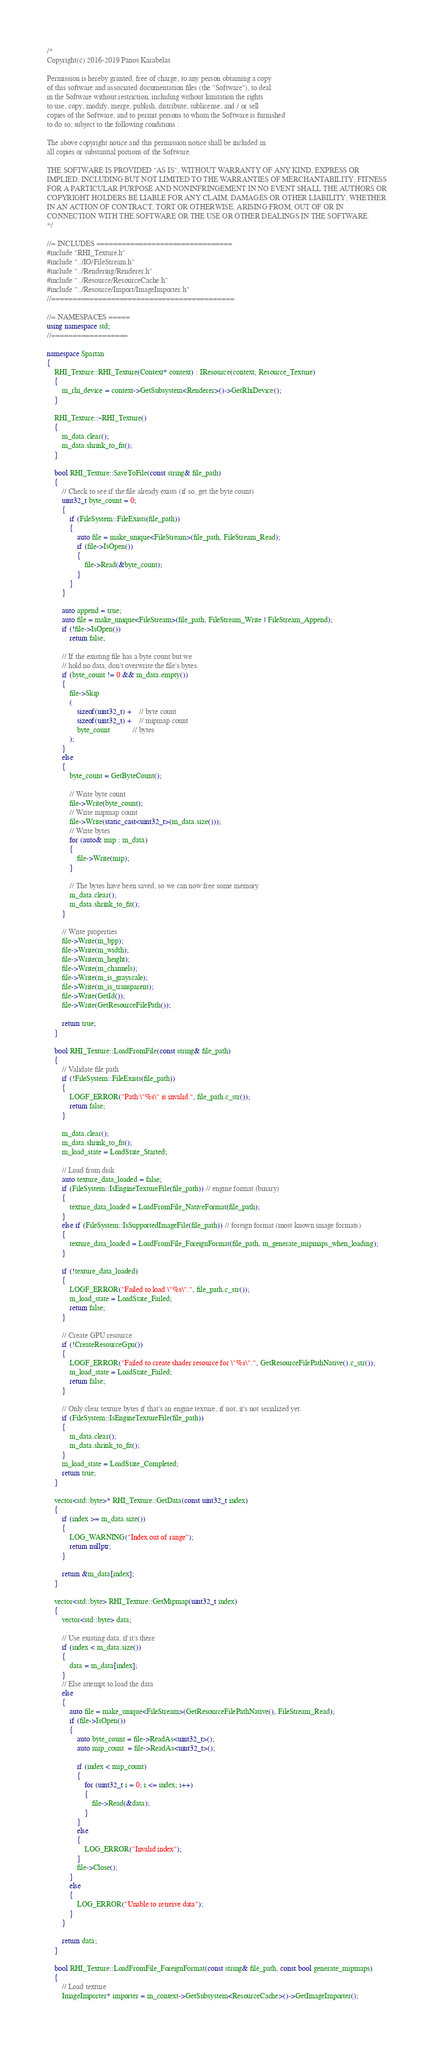Convert code to text. <code><loc_0><loc_0><loc_500><loc_500><_C++_>/*
Copyright(c) 2016-2019 Panos Karabelas

Permission is hereby granted, free of charge, to any person obtaining a copy
of this software and associated documentation files (the "Software"), to deal
in the Software without restriction, including without limitation the rights
to use, copy, modify, merge, publish, distribute, sublicense, and / or sell
copies of the Software, and to permit persons to whom the Software is furnished
to do so, subject to the following conditions :

The above copyright notice and this permission notice shall be included in
all copies or substantial portions of the Software.

THE SOFTWARE IS PROVIDED "AS IS", WITHOUT WARRANTY OF ANY KIND, EXPRESS OR
IMPLIED, INCLUDING BUT NOT LIMITED TO THE WARRANTIES OF MERCHANTABILITY, FITNESS
FOR A PARTICULAR PURPOSE AND NONINFRINGEMENT.IN NO EVENT SHALL THE AUTHORS OR
COPYRIGHT HOLDERS BE LIABLE FOR ANY CLAIM, DAMAGES OR OTHER LIABILITY, WHETHER
IN AN ACTION OF CONTRACT, TORT OR OTHERWISE, ARISING FROM, OUT OF OR IN
CONNECTION WITH THE SOFTWARE OR THE USE OR OTHER DEALINGS IN THE SOFTWARE.
*/

//= INCLUDES ================================
#include "RHI_Texture.h"
#include "../IO/FileStream.h"
#include "../Rendering/Renderer.h"
#include "../Resource/ResourceCache.h"
#include "../Resource/Import/ImageImporter.h"
//===========================================

//= NAMESPACES =====
using namespace std;
//==================

namespace Spartan
{
	RHI_Texture::RHI_Texture(Context* context) : IResource(context, Resource_Texture)
	{
		m_rhi_device = context->GetSubsystem<Renderer>()->GetRhiDevice();
	}

	RHI_Texture::~RHI_Texture()
	{
		m_data.clear();
		m_data.shrink_to_fit();
	}

	bool RHI_Texture::SaveToFile(const string& file_path)
	{
		// Check to see if the file already exists (if so, get the byte count)
		uint32_t byte_count = 0;
		{
			if (FileSystem::FileExists(file_path))
			{
				auto file = make_unique<FileStream>(file_path, FileStream_Read);
				if (file->IsOpen())
				{
					file->Read(&byte_count);
				}
			}
		}

		auto append = true;
		auto file = make_unique<FileStream>(file_path, FileStream_Write | FileStream_Append);
		if (!file->IsOpen())
			return false;

		// If the existing file has a byte count but we 
		// hold no data, don't overwrite the file's bytes.
		if (byte_count != 0 && m_data.empty())
		{
			file->Skip
			(
				sizeof(uint32_t) +	// byte count
				sizeof(uint32_t) +	// mipmap count
				byte_count			// bytes
			);
		}
		else
		{
			byte_count = GetByteCount();

			// Write byte count
			file->Write(byte_count);
			// Write mipmap count
			file->Write(static_cast<uint32_t>(m_data.size()));
			// Write bytes
			for (auto& mip : m_data)
			{
				file->Write(mip);
			}

			// The bytes have been saved, so we can now free some memory
			m_data.clear();
			m_data.shrink_to_fit();
		}

		// Write properties
		file->Write(m_bpp);
		file->Write(m_width);
		file->Write(m_height);
		file->Write(m_channels);
		file->Write(m_is_grayscale);
		file->Write(m_is_transparent);
		file->Write(GetId());
		file->Write(GetResourceFilePath());

		return true;
	}

	bool RHI_Texture::LoadFromFile(const string& file_path)
	{
		// Validate file path
		if (!FileSystem::FileExists(file_path))
		{
			LOGF_ERROR("Path \"%s\" is invalid.", file_path.c_str());
			return false;
		}

		m_data.clear();
		m_data.shrink_to_fit();
		m_load_state = LoadState_Started;

		// Load from disk
		auto texture_data_loaded = false;		
		if (FileSystem::IsEngineTextureFile(file_path)) // engine format (binary)
		{
			texture_data_loaded = LoadFromFile_NativeFormat(file_path);
		}	
		else if (FileSystem::IsSupportedImageFile(file_path)) // foreign format (most known image formats)
		{
			texture_data_loaded = LoadFromFile_ForeignFormat(file_path, m_generate_mipmaps_when_loading);
		}

		if (!texture_data_loaded)
		{
			LOGF_ERROR("Failed to load \"%s\".", file_path.c_str());
			m_load_state = LoadState_Failed;
			return false;
		}

		// Create GPU resource
		if (!CreateResourceGpu())
		{
			LOGF_ERROR("Failed to create shader resource for \"%s\".", GetResourceFilePathNative().c_str());
			m_load_state = LoadState_Failed;
			return false;
		}

		// Only clear texture bytes if that's an engine texture, if not, it's not serialized yet.
		if (FileSystem::IsEngineTextureFile(file_path))
		{
			m_data.clear();
			m_data.shrink_to_fit();
		}
		m_load_state = LoadState_Completed;
		return true;
	}

	vector<std::byte>* RHI_Texture::GetData(const uint32_t index)
	{
		if (index >= m_data.size())
		{
			LOG_WARNING("Index out of range");
			return nullptr;
		}

		return &m_data[index];
	}

    vector<std::byte> RHI_Texture::GetMipmap(uint32_t index)
    {
        vector<std::byte> data;

        // Use existing data, if it's there
        if (index < m_data.size())
        {
            data = m_data[index];
        }
        // Else attempt to load the data
        else
        {
            auto file = make_unique<FileStream>(GetResourceFilePathNative(), FileStream_Read);
            if (file->IsOpen())
            {
                auto byte_count = file->ReadAs<uint32_t>();
                auto mip_count  = file->ReadAs<uint32_t>();

                if (index < mip_count)
                {
                    for (uint32_t i = 0; i <= index; i++)
                    {
                        file->Read(&data);
                    }
                }
                else
                {
                    LOG_ERROR("Invalid index");
                }
                file->Close();
            }
            else
            {
                LOG_ERROR("Unable to retreive data");
            }
        }

        return data;
    }

    bool RHI_Texture::LoadFromFile_ForeignFormat(const string& file_path, const bool generate_mipmaps)
	{
		// Load texture
		ImageImporter* importer = m_context->GetSubsystem<ResourceCache>()->GetImageImporter();	</code> 